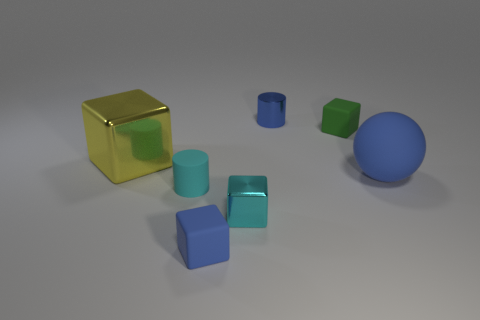Subtract all blue cubes. How many cubes are left? 3 Subtract all large metal cubes. How many cubes are left? 3 Add 2 big gray spheres. How many objects exist? 9 Subtract all cubes. How many objects are left? 3 Subtract 3 blocks. How many blocks are left? 1 Subtract all green spheres. How many blue cylinders are left? 1 Subtract all tiny blue metal objects. Subtract all spheres. How many objects are left? 5 Add 6 tiny cylinders. How many tiny cylinders are left? 8 Add 1 tiny green matte blocks. How many tiny green matte blocks exist? 2 Subtract 1 blue cubes. How many objects are left? 6 